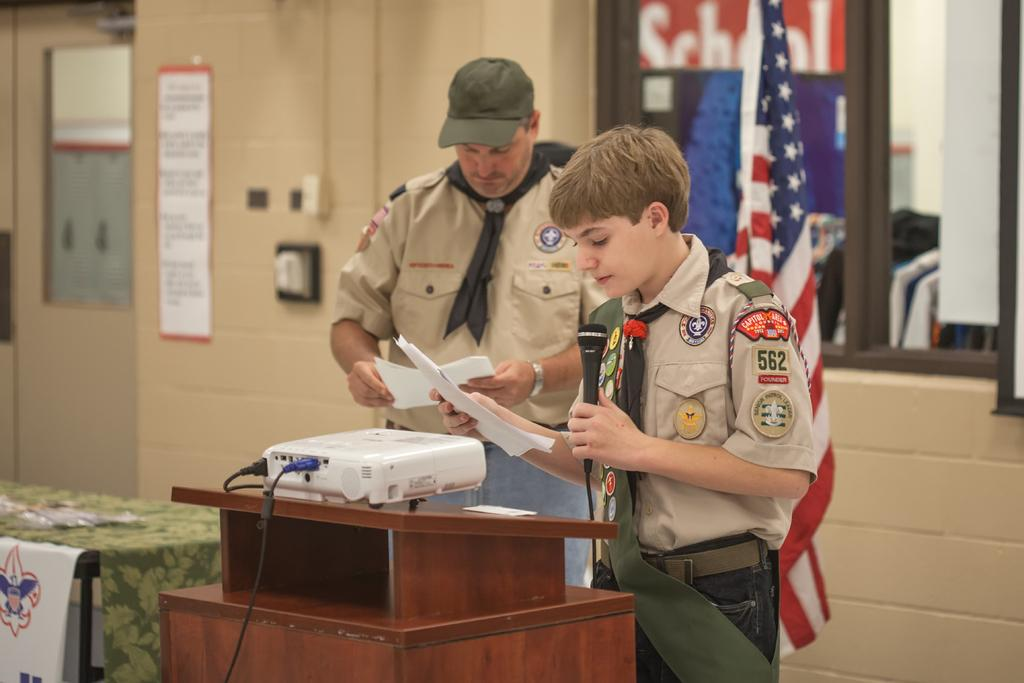How many people are present in the image? There are two people, a man and a woman, present in the image. What are the man and woman holding in the image? Both the man and woman are holding papers in the image. What object is in front of the man and woman? There is a projector in front of them. What is the woman holding in addition to the papers? The woman is holding a microphone in the image. What can be seen in the background of the image? There is a flag in the background of the image. What type of scientific experiment can be seen in the image? There is no scientific experiment visible in the image. How does the light in the room affect the image? The facts provided do not mention any specific lighting conditions, so it is not possible to determine how the light in the room affects the image. 